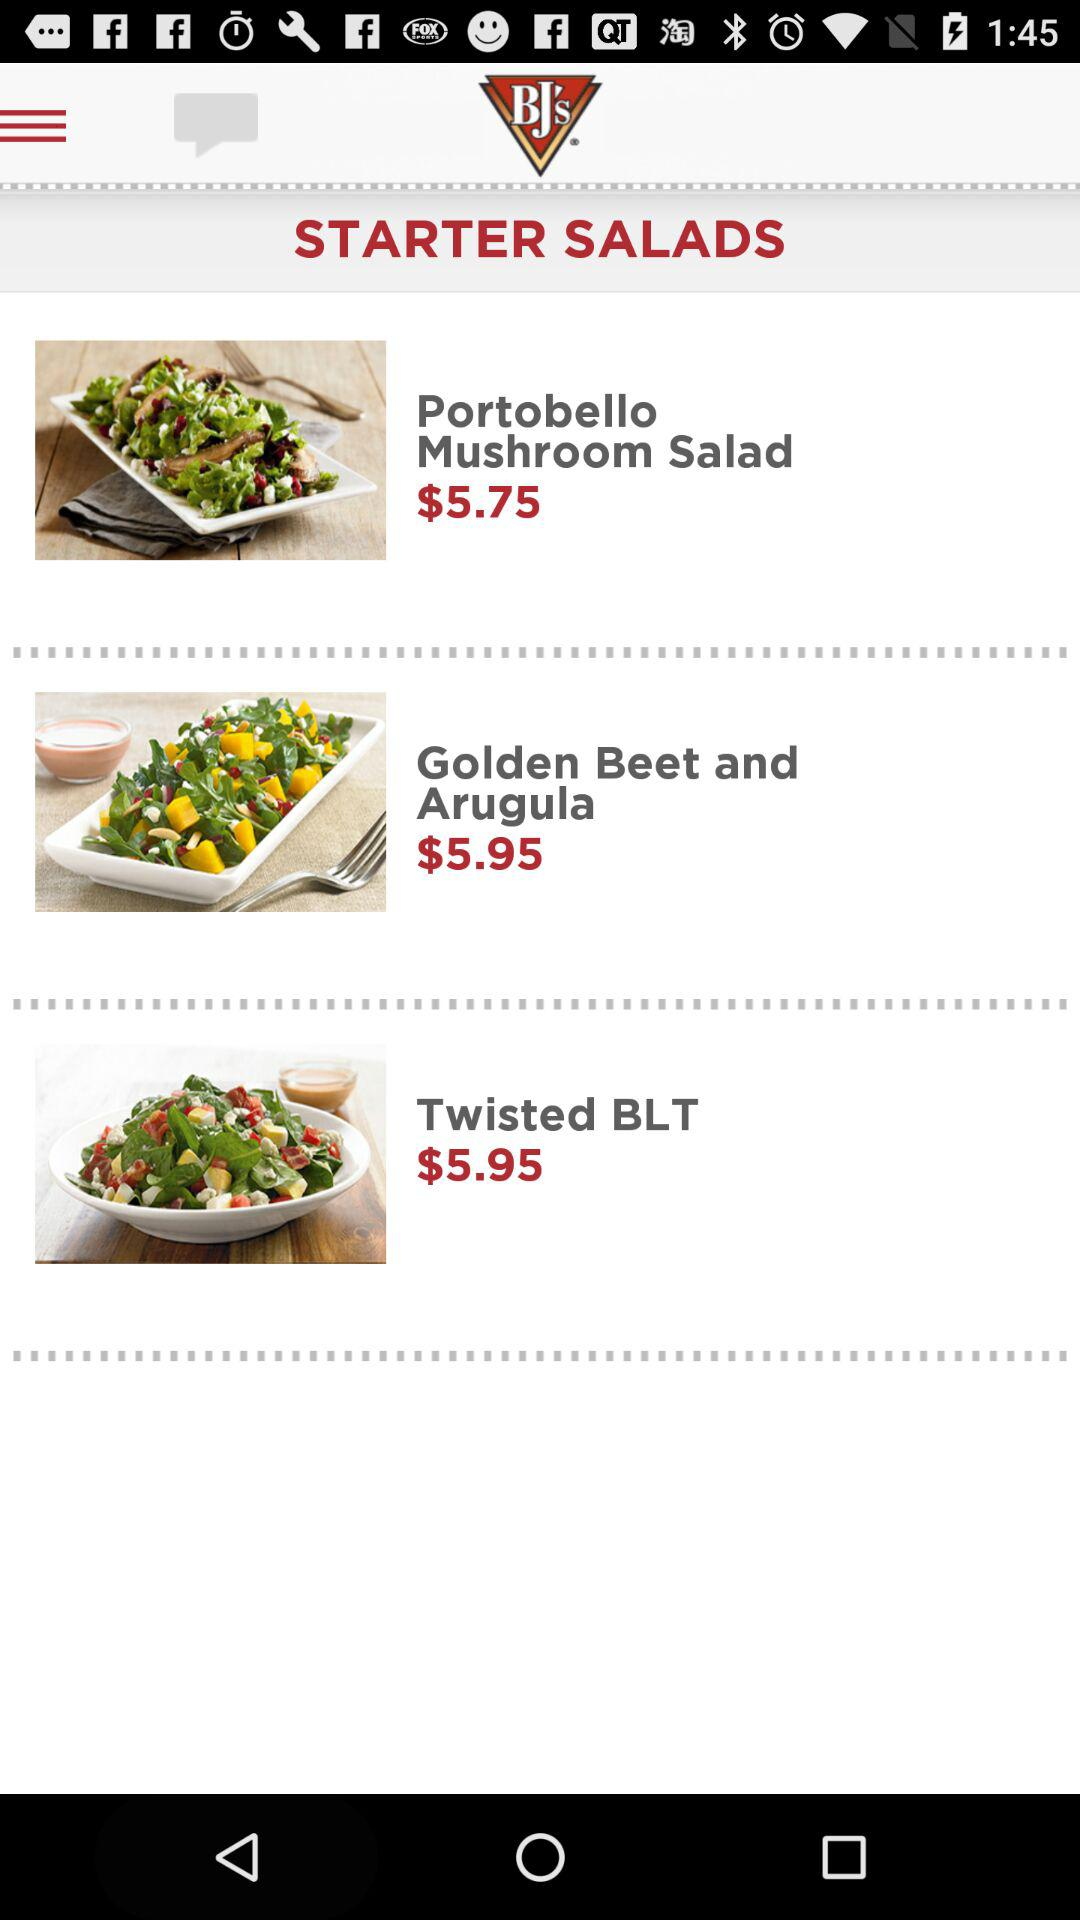What is the price of "Golden Beet and Arugula"? The price of "Golden Beet and Arugula" is $5.95. 